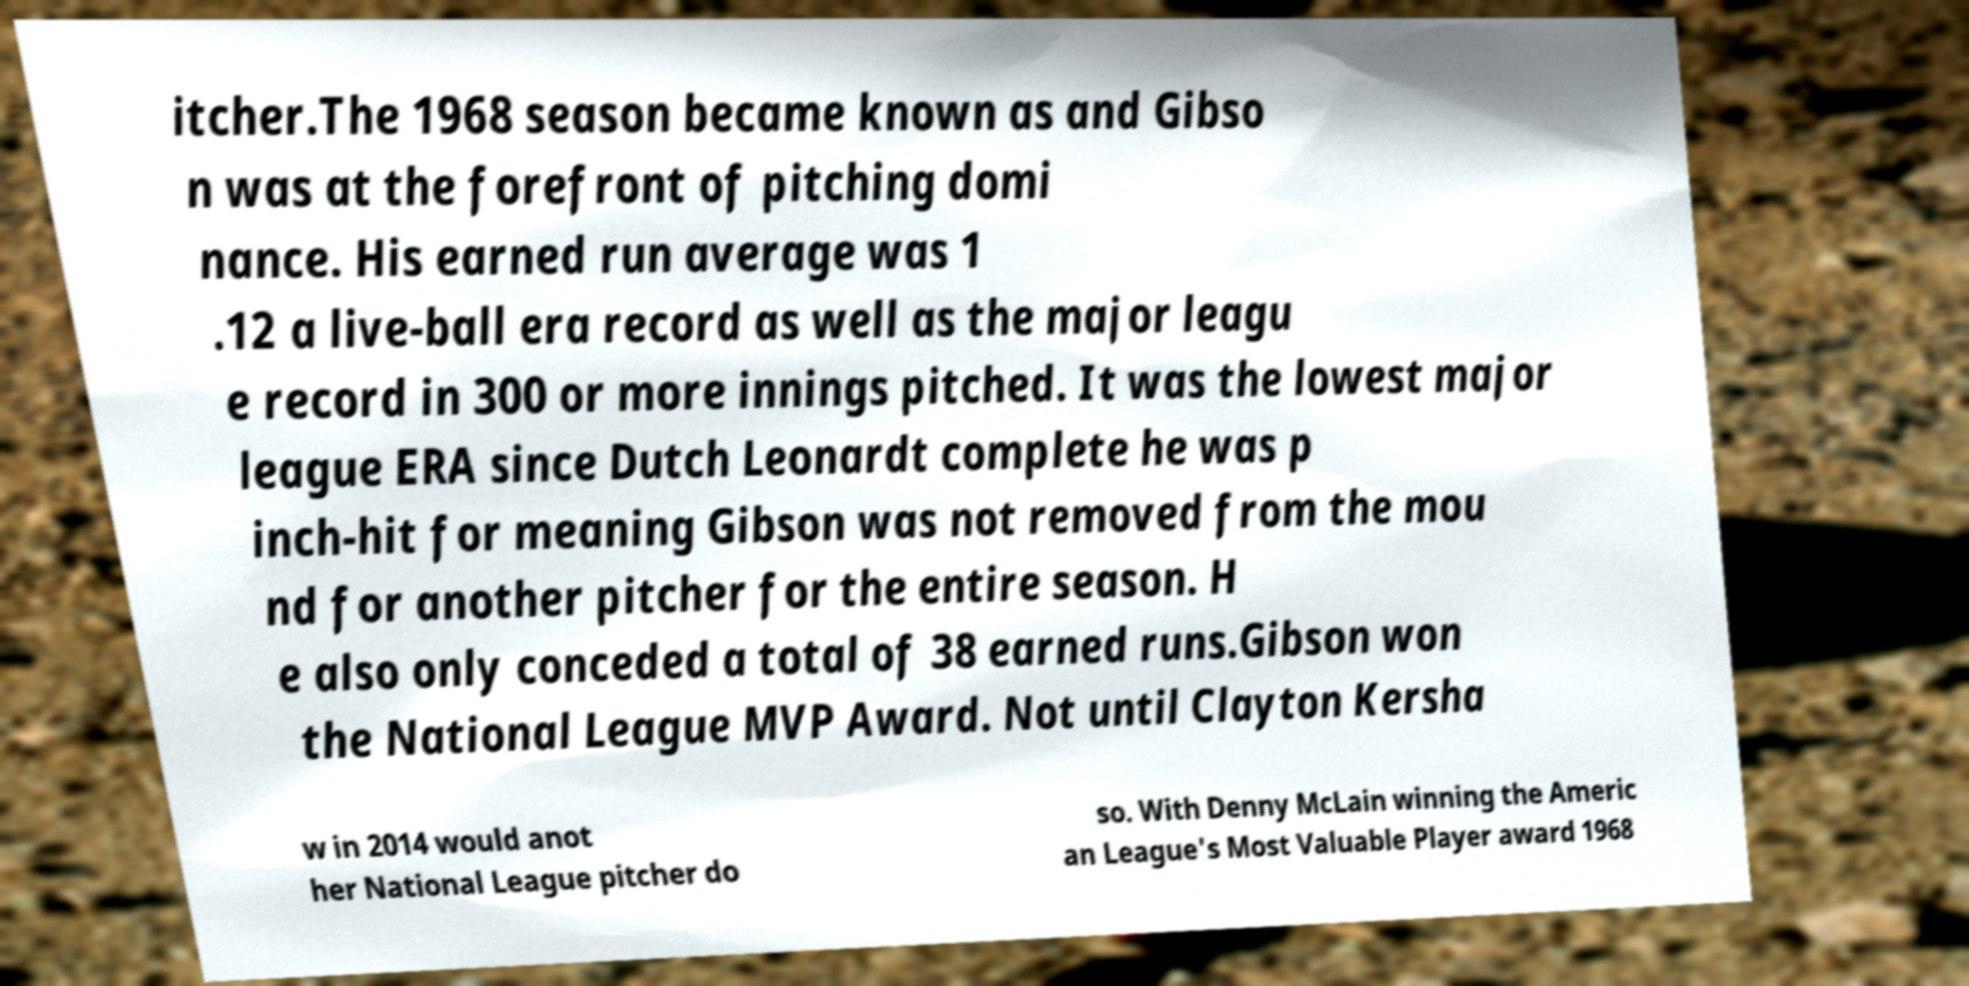Could you assist in decoding the text presented in this image and type it out clearly? itcher.The 1968 season became known as and Gibso n was at the forefront of pitching domi nance. His earned run average was 1 .12 a live-ball era record as well as the major leagu e record in 300 or more innings pitched. It was the lowest major league ERA since Dutch Leonardt complete he was p inch-hit for meaning Gibson was not removed from the mou nd for another pitcher for the entire season. H e also only conceded a total of 38 earned runs.Gibson won the National League MVP Award. Not until Clayton Kersha w in 2014 would anot her National League pitcher do so. With Denny McLain winning the Americ an League's Most Valuable Player award 1968 